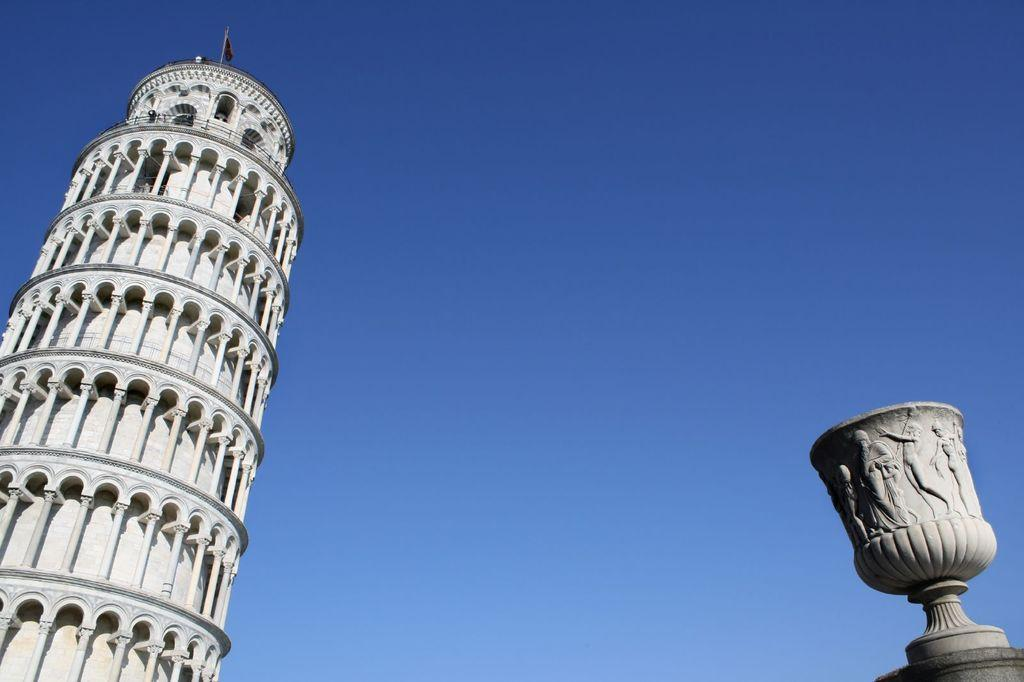What is the main subject on the left side of the image? There is a leaning tower of pizza on the left side of the image. What can be seen at the top of the image? The sky is visible at the top of the image. What object is located on the right side of the image? There is a cement cup on the right side of the image. What is a notable feature of the cement cup? The cement cup has engravings on it. Can you describe the insect that is crawling on the back of the leaning tower of pizza? There is no insect present in the image; it only features a leaning tower of pizza, the sky, and a cement cup with engravings. 